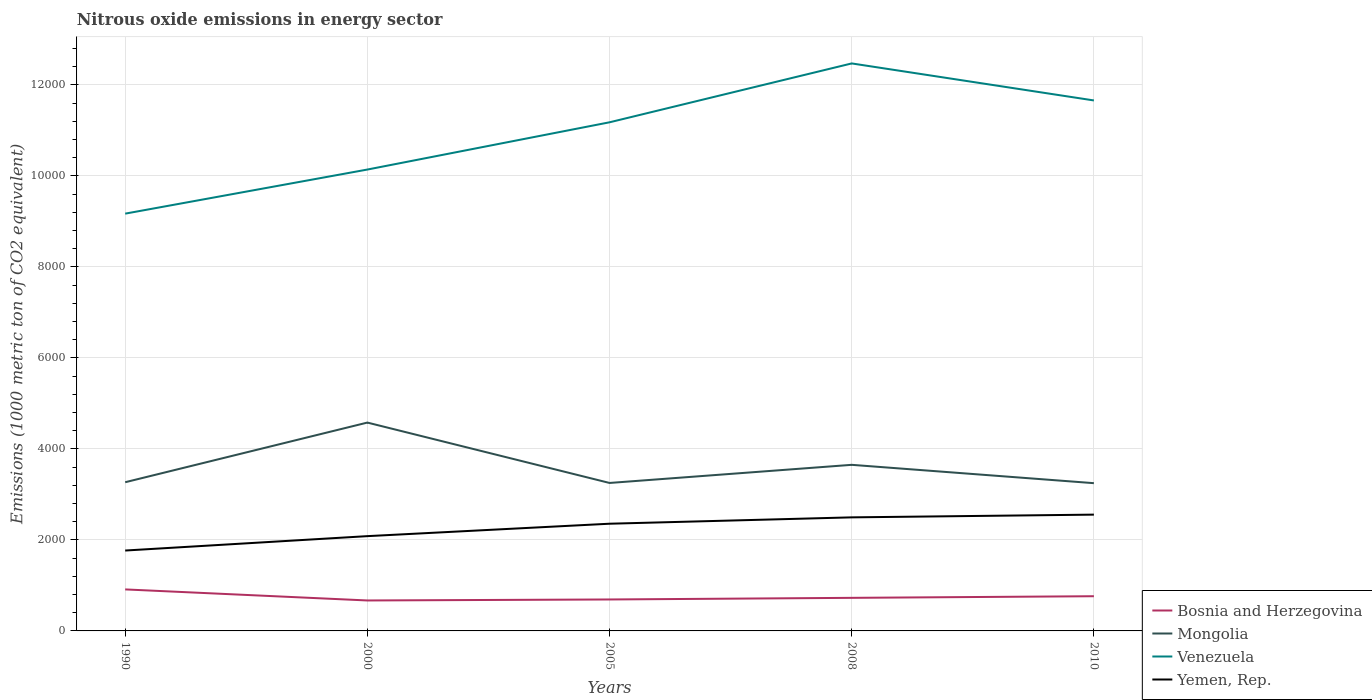How many different coloured lines are there?
Your answer should be compact. 4. Does the line corresponding to Yemen, Rep. intersect with the line corresponding to Bosnia and Herzegovina?
Keep it short and to the point. No. Is the number of lines equal to the number of legend labels?
Your response must be concise. Yes. Across all years, what is the maximum amount of nitrous oxide emitted in Mongolia?
Your answer should be compact. 3247. In which year was the amount of nitrous oxide emitted in Venezuela maximum?
Your answer should be compact. 1990. What is the total amount of nitrous oxide emitted in Venezuela in the graph?
Give a very brief answer. -1038.4. What is the difference between the highest and the second highest amount of nitrous oxide emitted in Bosnia and Herzegovina?
Offer a very short reply. 242.9. How many lines are there?
Provide a short and direct response. 4. What is the difference between two consecutive major ticks on the Y-axis?
Ensure brevity in your answer.  2000. Does the graph contain any zero values?
Keep it short and to the point. No. Does the graph contain grids?
Keep it short and to the point. Yes. How are the legend labels stacked?
Ensure brevity in your answer.  Vertical. What is the title of the graph?
Ensure brevity in your answer.  Nitrous oxide emissions in energy sector. Does "Bhutan" appear as one of the legend labels in the graph?
Provide a succinct answer. No. What is the label or title of the X-axis?
Your answer should be very brief. Years. What is the label or title of the Y-axis?
Keep it short and to the point. Emissions (1000 metric ton of CO2 equivalent). What is the Emissions (1000 metric ton of CO2 equivalent) in Bosnia and Herzegovina in 1990?
Your answer should be compact. 912.2. What is the Emissions (1000 metric ton of CO2 equivalent) in Mongolia in 1990?
Offer a very short reply. 3267.8. What is the Emissions (1000 metric ton of CO2 equivalent) in Venezuela in 1990?
Your answer should be very brief. 9170.6. What is the Emissions (1000 metric ton of CO2 equivalent) in Yemen, Rep. in 1990?
Your answer should be very brief. 1766.7. What is the Emissions (1000 metric ton of CO2 equivalent) in Bosnia and Herzegovina in 2000?
Keep it short and to the point. 669.3. What is the Emissions (1000 metric ton of CO2 equivalent) in Mongolia in 2000?
Offer a very short reply. 4578.6. What is the Emissions (1000 metric ton of CO2 equivalent) in Venezuela in 2000?
Provide a succinct answer. 1.01e+04. What is the Emissions (1000 metric ton of CO2 equivalent) in Yemen, Rep. in 2000?
Ensure brevity in your answer.  2082.9. What is the Emissions (1000 metric ton of CO2 equivalent) in Bosnia and Herzegovina in 2005?
Provide a succinct answer. 691.3. What is the Emissions (1000 metric ton of CO2 equivalent) of Mongolia in 2005?
Your answer should be very brief. 3251.9. What is the Emissions (1000 metric ton of CO2 equivalent) of Venezuela in 2005?
Keep it short and to the point. 1.12e+04. What is the Emissions (1000 metric ton of CO2 equivalent) in Yemen, Rep. in 2005?
Offer a very short reply. 2356. What is the Emissions (1000 metric ton of CO2 equivalent) of Bosnia and Herzegovina in 2008?
Keep it short and to the point. 727.1. What is the Emissions (1000 metric ton of CO2 equivalent) of Mongolia in 2008?
Offer a very short reply. 3650.1. What is the Emissions (1000 metric ton of CO2 equivalent) of Venezuela in 2008?
Your answer should be very brief. 1.25e+04. What is the Emissions (1000 metric ton of CO2 equivalent) of Yemen, Rep. in 2008?
Make the answer very short. 2495.7. What is the Emissions (1000 metric ton of CO2 equivalent) in Bosnia and Herzegovina in 2010?
Your answer should be very brief. 762.6. What is the Emissions (1000 metric ton of CO2 equivalent) in Mongolia in 2010?
Offer a very short reply. 3247. What is the Emissions (1000 metric ton of CO2 equivalent) of Venezuela in 2010?
Ensure brevity in your answer.  1.17e+04. What is the Emissions (1000 metric ton of CO2 equivalent) of Yemen, Rep. in 2010?
Ensure brevity in your answer.  2555.7. Across all years, what is the maximum Emissions (1000 metric ton of CO2 equivalent) in Bosnia and Herzegovina?
Provide a succinct answer. 912.2. Across all years, what is the maximum Emissions (1000 metric ton of CO2 equivalent) in Mongolia?
Give a very brief answer. 4578.6. Across all years, what is the maximum Emissions (1000 metric ton of CO2 equivalent) of Venezuela?
Give a very brief answer. 1.25e+04. Across all years, what is the maximum Emissions (1000 metric ton of CO2 equivalent) in Yemen, Rep.?
Your answer should be compact. 2555.7. Across all years, what is the minimum Emissions (1000 metric ton of CO2 equivalent) of Bosnia and Herzegovina?
Ensure brevity in your answer.  669.3. Across all years, what is the minimum Emissions (1000 metric ton of CO2 equivalent) in Mongolia?
Make the answer very short. 3247. Across all years, what is the minimum Emissions (1000 metric ton of CO2 equivalent) in Venezuela?
Your answer should be very brief. 9170.6. Across all years, what is the minimum Emissions (1000 metric ton of CO2 equivalent) in Yemen, Rep.?
Your answer should be compact. 1766.7. What is the total Emissions (1000 metric ton of CO2 equivalent) of Bosnia and Herzegovina in the graph?
Give a very brief answer. 3762.5. What is the total Emissions (1000 metric ton of CO2 equivalent) in Mongolia in the graph?
Keep it short and to the point. 1.80e+04. What is the total Emissions (1000 metric ton of CO2 equivalent) of Venezuela in the graph?
Offer a terse response. 5.46e+04. What is the total Emissions (1000 metric ton of CO2 equivalent) of Yemen, Rep. in the graph?
Provide a succinct answer. 1.13e+04. What is the difference between the Emissions (1000 metric ton of CO2 equivalent) in Bosnia and Herzegovina in 1990 and that in 2000?
Give a very brief answer. 242.9. What is the difference between the Emissions (1000 metric ton of CO2 equivalent) of Mongolia in 1990 and that in 2000?
Ensure brevity in your answer.  -1310.8. What is the difference between the Emissions (1000 metric ton of CO2 equivalent) in Venezuela in 1990 and that in 2000?
Make the answer very short. -969. What is the difference between the Emissions (1000 metric ton of CO2 equivalent) of Yemen, Rep. in 1990 and that in 2000?
Give a very brief answer. -316.2. What is the difference between the Emissions (1000 metric ton of CO2 equivalent) in Bosnia and Herzegovina in 1990 and that in 2005?
Keep it short and to the point. 220.9. What is the difference between the Emissions (1000 metric ton of CO2 equivalent) of Venezuela in 1990 and that in 2005?
Offer a terse response. -2007.4. What is the difference between the Emissions (1000 metric ton of CO2 equivalent) in Yemen, Rep. in 1990 and that in 2005?
Make the answer very short. -589.3. What is the difference between the Emissions (1000 metric ton of CO2 equivalent) of Bosnia and Herzegovina in 1990 and that in 2008?
Ensure brevity in your answer.  185.1. What is the difference between the Emissions (1000 metric ton of CO2 equivalent) in Mongolia in 1990 and that in 2008?
Ensure brevity in your answer.  -382.3. What is the difference between the Emissions (1000 metric ton of CO2 equivalent) in Venezuela in 1990 and that in 2008?
Your response must be concise. -3301.1. What is the difference between the Emissions (1000 metric ton of CO2 equivalent) of Yemen, Rep. in 1990 and that in 2008?
Give a very brief answer. -729. What is the difference between the Emissions (1000 metric ton of CO2 equivalent) of Bosnia and Herzegovina in 1990 and that in 2010?
Your answer should be very brief. 149.6. What is the difference between the Emissions (1000 metric ton of CO2 equivalent) in Mongolia in 1990 and that in 2010?
Your answer should be compact. 20.8. What is the difference between the Emissions (1000 metric ton of CO2 equivalent) in Venezuela in 1990 and that in 2010?
Provide a short and direct response. -2487.6. What is the difference between the Emissions (1000 metric ton of CO2 equivalent) of Yemen, Rep. in 1990 and that in 2010?
Your answer should be very brief. -789. What is the difference between the Emissions (1000 metric ton of CO2 equivalent) of Mongolia in 2000 and that in 2005?
Give a very brief answer. 1326.7. What is the difference between the Emissions (1000 metric ton of CO2 equivalent) of Venezuela in 2000 and that in 2005?
Provide a succinct answer. -1038.4. What is the difference between the Emissions (1000 metric ton of CO2 equivalent) in Yemen, Rep. in 2000 and that in 2005?
Your response must be concise. -273.1. What is the difference between the Emissions (1000 metric ton of CO2 equivalent) in Bosnia and Herzegovina in 2000 and that in 2008?
Your response must be concise. -57.8. What is the difference between the Emissions (1000 metric ton of CO2 equivalent) of Mongolia in 2000 and that in 2008?
Your answer should be very brief. 928.5. What is the difference between the Emissions (1000 metric ton of CO2 equivalent) of Venezuela in 2000 and that in 2008?
Offer a very short reply. -2332.1. What is the difference between the Emissions (1000 metric ton of CO2 equivalent) of Yemen, Rep. in 2000 and that in 2008?
Keep it short and to the point. -412.8. What is the difference between the Emissions (1000 metric ton of CO2 equivalent) of Bosnia and Herzegovina in 2000 and that in 2010?
Your answer should be very brief. -93.3. What is the difference between the Emissions (1000 metric ton of CO2 equivalent) in Mongolia in 2000 and that in 2010?
Your answer should be compact. 1331.6. What is the difference between the Emissions (1000 metric ton of CO2 equivalent) of Venezuela in 2000 and that in 2010?
Offer a very short reply. -1518.6. What is the difference between the Emissions (1000 metric ton of CO2 equivalent) of Yemen, Rep. in 2000 and that in 2010?
Your response must be concise. -472.8. What is the difference between the Emissions (1000 metric ton of CO2 equivalent) in Bosnia and Herzegovina in 2005 and that in 2008?
Provide a short and direct response. -35.8. What is the difference between the Emissions (1000 metric ton of CO2 equivalent) of Mongolia in 2005 and that in 2008?
Offer a terse response. -398.2. What is the difference between the Emissions (1000 metric ton of CO2 equivalent) of Venezuela in 2005 and that in 2008?
Ensure brevity in your answer.  -1293.7. What is the difference between the Emissions (1000 metric ton of CO2 equivalent) in Yemen, Rep. in 2005 and that in 2008?
Make the answer very short. -139.7. What is the difference between the Emissions (1000 metric ton of CO2 equivalent) in Bosnia and Herzegovina in 2005 and that in 2010?
Your answer should be very brief. -71.3. What is the difference between the Emissions (1000 metric ton of CO2 equivalent) of Mongolia in 2005 and that in 2010?
Keep it short and to the point. 4.9. What is the difference between the Emissions (1000 metric ton of CO2 equivalent) of Venezuela in 2005 and that in 2010?
Offer a terse response. -480.2. What is the difference between the Emissions (1000 metric ton of CO2 equivalent) of Yemen, Rep. in 2005 and that in 2010?
Your answer should be very brief. -199.7. What is the difference between the Emissions (1000 metric ton of CO2 equivalent) in Bosnia and Herzegovina in 2008 and that in 2010?
Provide a succinct answer. -35.5. What is the difference between the Emissions (1000 metric ton of CO2 equivalent) in Mongolia in 2008 and that in 2010?
Your response must be concise. 403.1. What is the difference between the Emissions (1000 metric ton of CO2 equivalent) in Venezuela in 2008 and that in 2010?
Offer a terse response. 813.5. What is the difference between the Emissions (1000 metric ton of CO2 equivalent) in Yemen, Rep. in 2008 and that in 2010?
Your answer should be compact. -60. What is the difference between the Emissions (1000 metric ton of CO2 equivalent) in Bosnia and Herzegovina in 1990 and the Emissions (1000 metric ton of CO2 equivalent) in Mongolia in 2000?
Offer a very short reply. -3666.4. What is the difference between the Emissions (1000 metric ton of CO2 equivalent) of Bosnia and Herzegovina in 1990 and the Emissions (1000 metric ton of CO2 equivalent) of Venezuela in 2000?
Provide a short and direct response. -9227.4. What is the difference between the Emissions (1000 metric ton of CO2 equivalent) of Bosnia and Herzegovina in 1990 and the Emissions (1000 metric ton of CO2 equivalent) of Yemen, Rep. in 2000?
Give a very brief answer. -1170.7. What is the difference between the Emissions (1000 metric ton of CO2 equivalent) in Mongolia in 1990 and the Emissions (1000 metric ton of CO2 equivalent) in Venezuela in 2000?
Your response must be concise. -6871.8. What is the difference between the Emissions (1000 metric ton of CO2 equivalent) of Mongolia in 1990 and the Emissions (1000 metric ton of CO2 equivalent) of Yemen, Rep. in 2000?
Your answer should be very brief. 1184.9. What is the difference between the Emissions (1000 metric ton of CO2 equivalent) of Venezuela in 1990 and the Emissions (1000 metric ton of CO2 equivalent) of Yemen, Rep. in 2000?
Offer a very short reply. 7087.7. What is the difference between the Emissions (1000 metric ton of CO2 equivalent) of Bosnia and Herzegovina in 1990 and the Emissions (1000 metric ton of CO2 equivalent) of Mongolia in 2005?
Ensure brevity in your answer.  -2339.7. What is the difference between the Emissions (1000 metric ton of CO2 equivalent) in Bosnia and Herzegovina in 1990 and the Emissions (1000 metric ton of CO2 equivalent) in Venezuela in 2005?
Offer a terse response. -1.03e+04. What is the difference between the Emissions (1000 metric ton of CO2 equivalent) in Bosnia and Herzegovina in 1990 and the Emissions (1000 metric ton of CO2 equivalent) in Yemen, Rep. in 2005?
Offer a terse response. -1443.8. What is the difference between the Emissions (1000 metric ton of CO2 equivalent) of Mongolia in 1990 and the Emissions (1000 metric ton of CO2 equivalent) of Venezuela in 2005?
Give a very brief answer. -7910.2. What is the difference between the Emissions (1000 metric ton of CO2 equivalent) of Mongolia in 1990 and the Emissions (1000 metric ton of CO2 equivalent) of Yemen, Rep. in 2005?
Ensure brevity in your answer.  911.8. What is the difference between the Emissions (1000 metric ton of CO2 equivalent) in Venezuela in 1990 and the Emissions (1000 metric ton of CO2 equivalent) in Yemen, Rep. in 2005?
Your response must be concise. 6814.6. What is the difference between the Emissions (1000 metric ton of CO2 equivalent) in Bosnia and Herzegovina in 1990 and the Emissions (1000 metric ton of CO2 equivalent) in Mongolia in 2008?
Your response must be concise. -2737.9. What is the difference between the Emissions (1000 metric ton of CO2 equivalent) in Bosnia and Herzegovina in 1990 and the Emissions (1000 metric ton of CO2 equivalent) in Venezuela in 2008?
Provide a short and direct response. -1.16e+04. What is the difference between the Emissions (1000 metric ton of CO2 equivalent) of Bosnia and Herzegovina in 1990 and the Emissions (1000 metric ton of CO2 equivalent) of Yemen, Rep. in 2008?
Ensure brevity in your answer.  -1583.5. What is the difference between the Emissions (1000 metric ton of CO2 equivalent) of Mongolia in 1990 and the Emissions (1000 metric ton of CO2 equivalent) of Venezuela in 2008?
Ensure brevity in your answer.  -9203.9. What is the difference between the Emissions (1000 metric ton of CO2 equivalent) of Mongolia in 1990 and the Emissions (1000 metric ton of CO2 equivalent) of Yemen, Rep. in 2008?
Make the answer very short. 772.1. What is the difference between the Emissions (1000 metric ton of CO2 equivalent) of Venezuela in 1990 and the Emissions (1000 metric ton of CO2 equivalent) of Yemen, Rep. in 2008?
Provide a short and direct response. 6674.9. What is the difference between the Emissions (1000 metric ton of CO2 equivalent) in Bosnia and Herzegovina in 1990 and the Emissions (1000 metric ton of CO2 equivalent) in Mongolia in 2010?
Your answer should be very brief. -2334.8. What is the difference between the Emissions (1000 metric ton of CO2 equivalent) in Bosnia and Herzegovina in 1990 and the Emissions (1000 metric ton of CO2 equivalent) in Venezuela in 2010?
Make the answer very short. -1.07e+04. What is the difference between the Emissions (1000 metric ton of CO2 equivalent) of Bosnia and Herzegovina in 1990 and the Emissions (1000 metric ton of CO2 equivalent) of Yemen, Rep. in 2010?
Provide a succinct answer. -1643.5. What is the difference between the Emissions (1000 metric ton of CO2 equivalent) of Mongolia in 1990 and the Emissions (1000 metric ton of CO2 equivalent) of Venezuela in 2010?
Provide a succinct answer. -8390.4. What is the difference between the Emissions (1000 metric ton of CO2 equivalent) of Mongolia in 1990 and the Emissions (1000 metric ton of CO2 equivalent) of Yemen, Rep. in 2010?
Provide a short and direct response. 712.1. What is the difference between the Emissions (1000 metric ton of CO2 equivalent) of Venezuela in 1990 and the Emissions (1000 metric ton of CO2 equivalent) of Yemen, Rep. in 2010?
Your answer should be very brief. 6614.9. What is the difference between the Emissions (1000 metric ton of CO2 equivalent) of Bosnia and Herzegovina in 2000 and the Emissions (1000 metric ton of CO2 equivalent) of Mongolia in 2005?
Your answer should be very brief. -2582.6. What is the difference between the Emissions (1000 metric ton of CO2 equivalent) in Bosnia and Herzegovina in 2000 and the Emissions (1000 metric ton of CO2 equivalent) in Venezuela in 2005?
Your response must be concise. -1.05e+04. What is the difference between the Emissions (1000 metric ton of CO2 equivalent) in Bosnia and Herzegovina in 2000 and the Emissions (1000 metric ton of CO2 equivalent) in Yemen, Rep. in 2005?
Keep it short and to the point. -1686.7. What is the difference between the Emissions (1000 metric ton of CO2 equivalent) in Mongolia in 2000 and the Emissions (1000 metric ton of CO2 equivalent) in Venezuela in 2005?
Your response must be concise. -6599.4. What is the difference between the Emissions (1000 metric ton of CO2 equivalent) of Mongolia in 2000 and the Emissions (1000 metric ton of CO2 equivalent) of Yemen, Rep. in 2005?
Your response must be concise. 2222.6. What is the difference between the Emissions (1000 metric ton of CO2 equivalent) in Venezuela in 2000 and the Emissions (1000 metric ton of CO2 equivalent) in Yemen, Rep. in 2005?
Ensure brevity in your answer.  7783.6. What is the difference between the Emissions (1000 metric ton of CO2 equivalent) in Bosnia and Herzegovina in 2000 and the Emissions (1000 metric ton of CO2 equivalent) in Mongolia in 2008?
Provide a succinct answer. -2980.8. What is the difference between the Emissions (1000 metric ton of CO2 equivalent) in Bosnia and Herzegovina in 2000 and the Emissions (1000 metric ton of CO2 equivalent) in Venezuela in 2008?
Your response must be concise. -1.18e+04. What is the difference between the Emissions (1000 metric ton of CO2 equivalent) in Bosnia and Herzegovina in 2000 and the Emissions (1000 metric ton of CO2 equivalent) in Yemen, Rep. in 2008?
Provide a short and direct response. -1826.4. What is the difference between the Emissions (1000 metric ton of CO2 equivalent) in Mongolia in 2000 and the Emissions (1000 metric ton of CO2 equivalent) in Venezuela in 2008?
Your response must be concise. -7893.1. What is the difference between the Emissions (1000 metric ton of CO2 equivalent) of Mongolia in 2000 and the Emissions (1000 metric ton of CO2 equivalent) of Yemen, Rep. in 2008?
Offer a very short reply. 2082.9. What is the difference between the Emissions (1000 metric ton of CO2 equivalent) in Venezuela in 2000 and the Emissions (1000 metric ton of CO2 equivalent) in Yemen, Rep. in 2008?
Ensure brevity in your answer.  7643.9. What is the difference between the Emissions (1000 metric ton of CO2 equivalent) of Bosnia and Herzegovina in 2000 and the Emissions (1000 metric ton of CO2 equivalent) of Mongolia in 2010?
Offer a terse response. -2577.7. What is the difference between the Emissions (1000 metric ton of CO2 equivalent) of Bosnia and Herzegovina in 2000 and the Emissions (1000 metric ton of CO2 equivalent) of Venezuela in 2010?
Offer a terse response. -1.10e+04. What is the difference between the Emissions (1000 metric ton of CO2 equivalent) in Bosnia and Herzegovina in 2000 and the Emissions (1000 metric ton of CO2 equivalent) in Yemen, Rep. in 2010?
Make the answer very short. -1886.4. What is the difference between the Emissions (1000 metric ton of CO2 equivalent) in Mongolia in 2000 and the Emissions (1000 metric ton of CO2 equivalent) in Venezuela in 2010?
Offer a terse response. -7079.6. What is the difference between the Emissions (1000 metric ton of CO2 equivalent) in Mongolia in 2000 and the Emissions (1000 metric ton of CO2 equivalent) in Yemen, Rep. in 2010?
Make the answer very short. 2022.9. What is the difference between the Emissions (1000 metric ton of CO2 equivalent) in Venezuela in 2000 and the Emissions (1000 metric ton of CO2 equivalent) in Yemen, Rep. in 2010?
Your answer should be compact. 7583.9. What is the difference between the Emissions (1000 metric ton of CO2 equivalent) of Bosnia and Herzegovina in 2005 and the Emissions (1000 metric ton of CO2 equivalent) of Mongolia in 2008?
Make the answer very short. -2958.8. What is the difference between the Emissions (1000 metric ton of CO2 equivalent) in Bosnia and Herzegovina in 2005 and the Emissions (1000 metric ton of CO2 equivalent) in Venezuela in 2008?
Provide a succinct answer. -1.18e+04. What is the difference between the Emissions (1000 metric ton of CO2 equivalent) of Bosnia and Herzegovina in 2005 and the Emissions (1000 metric ton of CO2 equivalent) of Yemen, Rep. in 2008?
Offer a very short reply. -1804.4. What is the difference between the Emissions (1000 metric ton of CO2 equivalent) in Mongolia in 2005 and the Emissions (1000 metric ton of CO2 equivalent) in Venezuela in 2008?
Ensure brevity in your answer.  -9219.8. What is the difference between the Emissions (1000 metric ton of CO2 equivalent) in Mongolia in 2005 and the Emissions (1000 metric ton of CO2 equivalent) in Yemen, Rep. in 2008?
Provide a short and direct response. 756.2. What is the difference between the Emissions (1000 metric ton of CO2 equivalent) in Venezuela in 2005 and the Emissions (1000 metric ton of CO2 equivalent) in Yemen, Rep. in 2008?
Offer a terse response. 8682.3. What is the difference between the Emissions (1000 metric ton of CO2 equivalent) in Bosnia and Herzegovina in 2005 and the Emissions (1000 metric ton of CO2 equivalent) in Mongolia in 2010?
Offer a terse response. -2555.7. What is the difference between the Emissions (1000 metric ton of CO2 equivalent) of Bosnia and Herzegovina in 2005 and the Emissions (1000 metric ton of CO2 equivalent) of Venezuela in 2010?
Your answer should be compact. -1.10e+04. What is the difference between the Emissions (1000 metric ton of CO2 equivalent) of Bosnia and Herzegovina in 2005 and the Emissions (1000 metric ton of CO2 equivalent) of Yemen, Rep. in 2010?
Provide a succinct answer. -1864.4. What is the difference between the Emissions (1000 metric ton of CO2 equivalent) of Mongolia in 2005 and the Emissions (1000 metric ton of CO2 equivalent) of Venezuela in 2010?
Your answer should be compact. -8406.3. What is the difference between the Emissions (1000 metric ton of CO2 equivalent) of Mongolia in 2005 and the Emissions (1000 metric ton of CO2 equivalent) of Yemen, Rep. in 2010?
Give a very brief answer. 696.2. What is the difference between the Emissions (1000 metric ton of CO2 equivalent) of Venezuela in 2005 and the Emissions (1000 metric ton of CO2 equivalent) of Yemen, Rep. in 2010?
Offer a very short reply. 8622.3. What is the difference between the Emissions (1000 metric ton of CO2 equivalent) of Bosnia and Herzegovina in 2008 and the Emissions (1000 metric ton of CO2 equivalent) of Mongolia in 2010?
Make the answer very short. -2519.9. What is the difference between the Emissions (1000 metric ton of CO2 equivalent) of Bosnia and Herzegovina in 2008 and the Emissions (1000 metric ton of CO2 equivalent) of Venezuela in 2010?
Your response must be concise. -1.09e+04. What is the difference between the Emissions (1000 metric ton of CO2 equivalent) in Bosnia and Herzegovina in 2008 and the Emissions (1000 metric ton of CO2 equivalent) in Yemen, Rep. in 2010?
Provide a succinct answer. -1828.6. What is the difference between the Emissions (1000 metric ton of CO2 equivalent) of Mongolia in 2008 and the Emissions (1000 metric ton of CO2 equivalent) of Venezuela in 2010?
Ensure brevity in your answer.  -8008.1. What is the difference between the Emissions (1000 metric ton of CO2 equivalent) of Mongolia in 2008 and the Emissions (1000 metric ton of CO2 equivalent) of Yemen, Rep. in 2010?
Your answer should be very brief. 1094.4. What is the difference between the Emissions (1000 metric ton of CO2 equivalent) of Venezuela in 2008 and the Emissions (1000 metric ton of CO2 equivalent) of Yemen, Rep. in 2010?
Ensure brevity in your answer.  9916. What is the average Emissions (1000 metric ton of CO2 equivalent) of Bosnia and Herzegovina per year?
Provide a short and direct response. 752.5. What is the average Emissions (1000 metric ton of CO2 equivalent) in Mongolia per year?
Provide a short and direct response. 3599.08. What is the average Emissions (1000 metric ton of CO2 equivalent) of Venezuela per year?
Offer a very short reply. 1.09e+04. What is the average Emissions (1000 metric ton of CO2 equivalent) of Yemen, Rep. per year?
Offer a very short reply. 2251.4. In the year 1990, what is the difference between the Emissions (1000 metric ton of CO2 equivalent) in Bosnia and Herzegovina and Emissions (1000 metric ton of CO2 equivalent) in Mongolia?
Offer a terse response. -2355.6. In the year 1990, what is the difference between the Emissions (1000 metric ton of CO2 equivalent) in Bosnia and Herzegovina and Emissions (1000 metric ton of CO2 equivalent) in Venezuela?
Offer a very short reply. -8258.4. In the year 1990, what is the difference between the Emissions (1000 metric ton of CO2 equivalent) of Bosnia and Herzegovina and Emissions (1000 metric ton of CO2 equivalent) of Yemen, Rep.?
Give a very brief answer. -854.5. In the year 1990, what is the difference between the Emissions (1000 metric ton of CO2 equivalent) of Mongolia and Emissions (1000 metric ton of CO2 equivalent) of Venezuela?
Offer a very short reply. -5902.8. In the year 1990, what is the difference between the Emissions (1000 metric ton of CO2 equivalent) of Mongolia and Emissions (1000 metric ton of CO2 equivalent) of Yemen, Rep.?
Provide a succinct answer. 1501.1. In the year 1990, what is the difference between the Emissions (1000 metric ton of CO2 equivalent) in Venezuela and Emissions (1000 metric ton of CO2 equivalent) in Yemen, Rep.?
Your answer should be compact. 7403.9. In the year 2000, what is the difference between the Emissions (1000 metric ton of CO2 equivalent) of Bosnia and Herzegovina and Emissions (1000 metric ton of CO2 equivalent) of Mongolia?
Keep it short and to the point. -3909.3. In the year 2000, what is the difference between the Emissions (1000 metric ton of CO2 equivalent) in Bosnia and Herzegovina and Emissions (1000 metric ton of CO2 equivalent) in Venezuela?
Keep it short and to the point. -9470.3. In the year 2000, what is the difference between the Emissions (1000 metric ton of CO2 equivalent) in Bosnia and Herzegovina and Emissions (1000 metric ton of CO2 equivalent) in Yemen, Rep.?
Provide a succinct answer. -1413.6. In the year 2000, what is the difference between the Emissions (1000 metric ton of CO2 equivalent) in Mongolia and Emissions (1000 metric ton of CO2 equivalent) in Venezuela?
Keep it short and to the point. -5561. In the year 2000, what is the difference between the Emissions (1000 metric ton of CO2 equivalent) of Mongolia and Emissions (1000 metric ton of CO2 equivalent) of Yemen, Rep.?
Provide a short and direct response. 2495.7. In the year 2000, what is the difference between the Emissions (1000 metric ton of CO2 equivalent) in Venezuela and Emissions (1000 metric ton of CO2 equivalent) in Yemen, Rep.?
Offer a terse response. 8056.7. In the year 2005, what is the difference between the Emissions (1000 metric ton of CO2 equivalent) of Bosnia and Herzegovina and Emissions (1000 metric ton of CO2 equivalent) of Mongolia?
Your answer should be very brief. -2560.6. In the year 2005, what is the difference between the Emissions (1000 metric ton of CO2 equivalent) in Bosnia and Herzegovina and Emissions (1000 metric ton of CO2 equivalent) in Venezuela?
Keep it short and to the point. -1.05e+04. In the year 2005, what is the difference between the Emissions (1000 metric ton of CO2 equivalent) in Bosnia and Herzegovina and Emissions (1000 metric ton of CO2 equivalent) in Yemen, Rep.?
Keep it short and to the point. -1664.7. In the year 2005, what is the difference between the Emissions (1000 metric ton of CO2 equivalent) of Mongolia and Emissions (1000 metric ton of CO2 equivalent) of Venezuela?
Make the answer very short. -7926.1. In the year 2005, what is the difference between the Emissions (1000 metric ton of CO2 equivalent) in Mongolia and Emissions (1000 metric ton of CO2 equivalent) in Yemen, Rep.?
Your answer should be compact. 895.9. In the year 2005, what is the difference between the Emissions (1000 metric ton of CO2 equivalent) in Venezuela and Emissions (1000 metric ton of CO2 equivalent) in Yemen, Rep.?
Offer a very short reply. 8822. In the year 2008, what is the difference between the Emissions (1000 metric ton of CO2 equivalent) of Bosnia and Herzegovina and Emissions (1000 metric ton of CO2 equivalent) of Mongolia?
Your answer should be very brief. -2923. In the year 2008, what is the difference between the Emissions (1000 metric ton of CO2 equivalent) of Bosnia and Herzegovina and Emissions (1000 metric ton of CO2 equivalent) of Venezuela?
Offer a terse response. -1.17e+04. In the year 2008, what is the difference between the Emissions (1000 metric ton of CO2 equivalent) of Bosnia and Herzegovina and Emissions (1000 metric ton of CO2 equivalent) of Yemen, Rep.?
Your answer should be compact. -1768.6. In the year 2008, what is the difference between the Emissions (1000 metric ton of CO2 equivalent) in Mongolia and Emissions (1000 metric ton of CO2 equivalent) in Venezuela?
Provide a succinct answer. -8821.6. In the year 2008, what is the difference between the Emissions (1000 metric ton of CO2 equivalent) of Mongolia and Emissions (1000 metric ton of CO2 equivalent) of Yemen, Rep.?
Offer a terse response. 1154.4. In the year 2008, what is the difference between the Emissions (1000 metric ton of CO2 equivalent) in Venezuela and Emissions (1000 metric ton of CO2 equivalent) in Yemen, Rep.?
Provide a short and direct response. 9976. In the year 2010, what is the difference between the Emissions (1000 metric ton of CO2 equivalent) in Bosnia and Herzegovina and Emissions (1000 metric ton of CO2 equivalent) in Mongolia?
Make the answer very short. -2484.4. In the year 2010, what is the difference between the Emissions (1000 metric ton of CO2 equivalent) in Bosnia and Herzegovina and Emissions (1000 metric ton of CO2 equivalent) in Venezuela?
Your response must be concise. -1.09e+04. In the year 2010, what is the difference between the Emissions (1000 metric ton of CO2 equivalent) of Bosnia and Herzegovina and Emissions (1000 metric ton of CO2 equivalent) of Yemen, Rep.?
Ensure brevity in your answer.  -1793.1. In the year 2010, what is the difference between the Emissions (1000 metric ton of CO2 equivalent) in Mongolia and Emissions (1000 metric ton of CO2 equivalent) in Venezuela?
Ensure brevity in your answer.  -8411.2. In the year 2010, what is the difference between the Emissions (1000 metric ton of CO2 equivalent) in Mongolia and Emissions (1000 metric ton of CO2 equivalent) in Yemen, Rep.?
Your response must be concise. 691.3. In the year 2010, what is the difference between the Emissions (1000 metric ton of CO2 equivalent) of Venezuela and Emissions (1000 metric ton of CO2 equivalent) of Yemen, Rep.?
Your response must be concise. 9102.5. What is the ratio of the Emissions (1000 metric ton of CO2 equivalent) in Bosnia and Herzegovina in 1990 to that in 2000?
Your answer should be compact. 1.36. What is the ratio of the Emissions (1000 metric ton of CO2 equivalent) in Mongolia in 1990 to that in 2000?
Offer a terse response. 0.71. What is the ratio of the Emissions (1000 metric ton of CO2 equivalent) of Venezuela in 1990 to that in 2000?
Your response must be concise. 0.9. What is the ratio of the Emissions (1000 metric ton of CO2 equivalent) in Yemen, Rep. in 1990 to that in 2000?
Give a very brief answer. 0.85. What is the ratio of the Emissions (1000 metric ton of CO2 equivalent) in Bosnia and Herzegovina in 1990 to that in 2005?
Your answer should be very brief. 1.32. What is the ratio of the Emissions (1000 metric ton of CO2 equivalent) in Venezuela in 1990 to that in 2005?
Your answer should be compact. 0.82. What is the ratio of the Emissions (1000 metric ton of CO2 equivalent) of Yemen, Rep. in 1990 to that in 2005?
Provide a short and direct response. 0.75. What is the ratio of the Emissions (1000 metric ton of CO2 equivalent) in Bosnia and Herzegovina in 1990 to that in 2008?
Provide a succinct answer. 1.25. What is the ratio of the Emissions (1000 metric ton of CO2 equivalent) of Mongolia in 1990 to that in 2008?
Your answer should be very brief. 0.9. What is the ratio of the Emissions (1000 metric ton of CO2 equivalent) of Venezuela in 1990 to that in 2008?
Ensure brevity in your answer.  0.74. What is the ratio of the Emissions (1000 metric ton of CO2 equivalent) in Yemen, Rep. in 1990 to that in 2008?
Provide a short and direct response. 0.71. What is the ratio of the Emissions (1000 metric ton of CO2 equivalent) in Bosnia and Herzegovina in 1990 to that in 2010?
Provide a short and direct response. 1.2. What is the ratio of the Emissions (1000 metric ton of CO2 equivalent) of Mongolia in 1990 to that in 2010?
Provide a succinct answer. 1.01. What is the ratio of the Emissions (1000 metric ton of CO2 equivalent) in Venezuela in 1990 to that in 2010?
Your response must be concise. 0.79. What is the ratio of the Emissions (1000 metric ton of CO2 equivalent) of Yemen, Rep. in 1990 to that in 2010?
Provide a succinct answer. 0.69. What is the ratio of the Emissions (1000 metric ton of CO2 equivalent) of Bosnia and Herzegovina in 2000 to that in 2005?
Provide a succinct answer. 0.97. What is the ratio of the Emissions (1000 metric ton of CO2 equivalent) of Mongolia in 2000 to that in 2005?
Offer a terse response. 1.41. What is the ratio of the Emissions (1000 metric ton of CO2 equivalent) of Venezuela in 2000 to that in 2005?
Keep it short and to the point. 0.91. What is the ratio of the Emissions (1000 metric ton of CO2 equivalent) in Yemen, Rep. in 2000 to that in 2005?
Provide a succinct answer. 0.88. What is the ratio of the Emissions (1000 metric ton of CO2 equivalent) in Bosnia and Herzegovina in 2000 to that in 2008?
Give a very brief answer. 0.92. What is the ratio of the Emissions (1000 metric ton of CO2 equivalent) in Mongolia in 2000 to that in 2008?
Make the answer very short. 1.25. What is the ratio of the Emissions (1000 metric ton of CO2 equivalent) of Venezuela in 2000 to that in 2008?
Your answer should be compact. 0.81. What is the ratio of the Emissions (1000 metric ton of CO2 equivalent) of Yemen, Rep. in 2000 to that in 2008?
Provide a succinct answer. 0.83. What is the ratio of the Emissions (1000 metric ton of CO2 equivalent) in Bosnia and Herzegovina in 2000 to that in 2010?
Your answer should be very brief. 0.88. What is the ratio of the Emissions (1000 metric ton of CO2 equivalent) of Mongolia in 2000 to that in 2010?
Ensure brevity in your answer.  1.41. What is the ratio of the Emissions (1000 metric ton of CO2 equivalent) of Venezuela in 2000 to that in 2010?
Ensure brevity in your answer.  0.87. What is the ratio of the Emissions (1000 metric ton of CO2 equivalent) of Yemen, Rep. in 2000 to that in 2010?
Your answer should be compact. 0.81. What is the ratio of the Emissions (1000 metric ton of CO2 equivalent) in Bosnia and Herzegovina in 2005 to that in 2008?
Your answer should be compact. 0.95. What is the ratio of the Emissions (1000 metric ton of CO2 equivalent) of Mongolia in 2005 to that in 2008?
Give a very brief answer. 0.89. What is the ratio of the Emissions (1000 metric ton of CO2 equivalent) in Venezuela in 2005 to that in 2008?
Ensure brevity in your answer.  0.9. What is the ratio of the Emissions (1000 metric ton of CO2 equivalent) in Yemen, Rep. in 2005 to that in 2008?
Provide a short and direct response. 0.94. What is the ratio of the Emissions (1000 metric ton of CO2 equivalent) in Bosnia and Herzegovina in 2005 to that in 2010?
Your response must be concise. 0.91. What is the ratio of the Emissions (1000 metric ton of CO2 equivalent) of Venezuela in 2005 to that in 2010?
Your response must be concise. 0.96. What is the ratio of the Emissions (1000 metric ton of CO2 equivalent) of Yemen, Rep. in 2005 to that in 2010?
Offer a terse response. 0.92. What is the ratio of the Emissions (1000 metric ton of CO2 equivalent) of Bosnia and Herzegovina in 2008 to that in 2010?
Your response must be concise. 0.95. What is the ratio of the Emissions (1000 metric ton of CO2 equivalent) of Mongolia in 2008 to that in 2010?
Your answer should be very brief. 1.12. What is the ratio of the Emissions (1000 metric ton of CO2 equivalent) in Venezuela in 2008 to that in 2010?
Ensure brevity in your answer.  1.07. What is the ratio of the Emissions (1000 metric ton of CO2 equivalent) in Yemen, Rep. in 2008 to that in 2010?
Offer a terse response. 0.98. What is the difference between the highest and the second highest Emissions (1000 metric ton of CO2 equivalent) in Bosnia and Herzegovina?
Give a very brief answer. 149.6. What is the difference between the highest and the second highest Emissions (1000 metric ton of CO2 equivalent) of Mongolia?
Your answer should be compact. 928.5. What is the difference between the highest and the second highest Emissions (1000 metric ton of CO2 equivalent) in Venezuela?
Make the answer very short. 813.5. What is the difference between the highest and the second highest Emissions (1000 metric ton of CO2 equivalent) in Yemen, Rep.?
Offer a terse response. 60. What is the difference between the highest and the lowest Emissions (1000 metric ton of CO2 equivalent) of Bosnia and Herzegovina?
Make the answer very short. 242.9. What is the difference between the highest and the lowest Emissions (1000 metric ton of CO2 equivalent) in Mongolia?
Provide a short and direct response. 1331.6. What is the difference between the highest and the lowest Emissions (1000 metric ton of CO2 equivalent) in Venezuela?
Your answer should be compact. 3301.1. What is the difference between the highest and the lowest Emissions (1000 metric ton of CO2 equivalent) of Yemen, Rep.?
Provide a succinct answer. 789. 